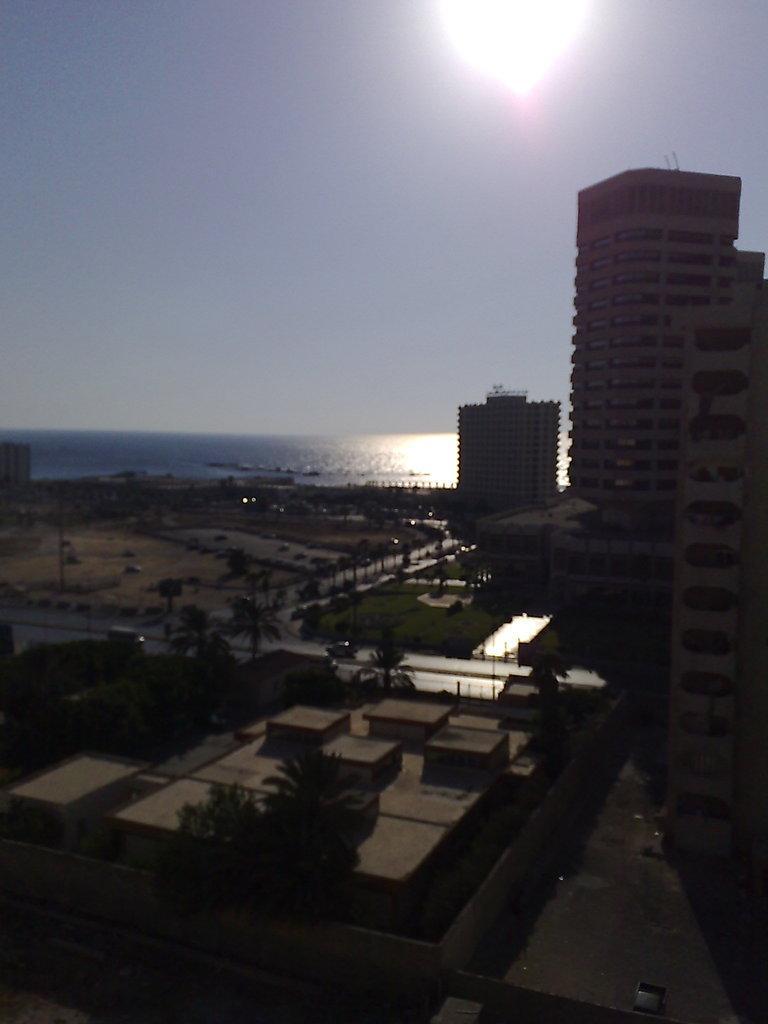Can you describe this image briefly? In this picture we can see a few trees and vehicles on the road. Some grass is visible on the ground. We can see a few buildings in the background. There is the water. We can see the sky on top of the picture. 